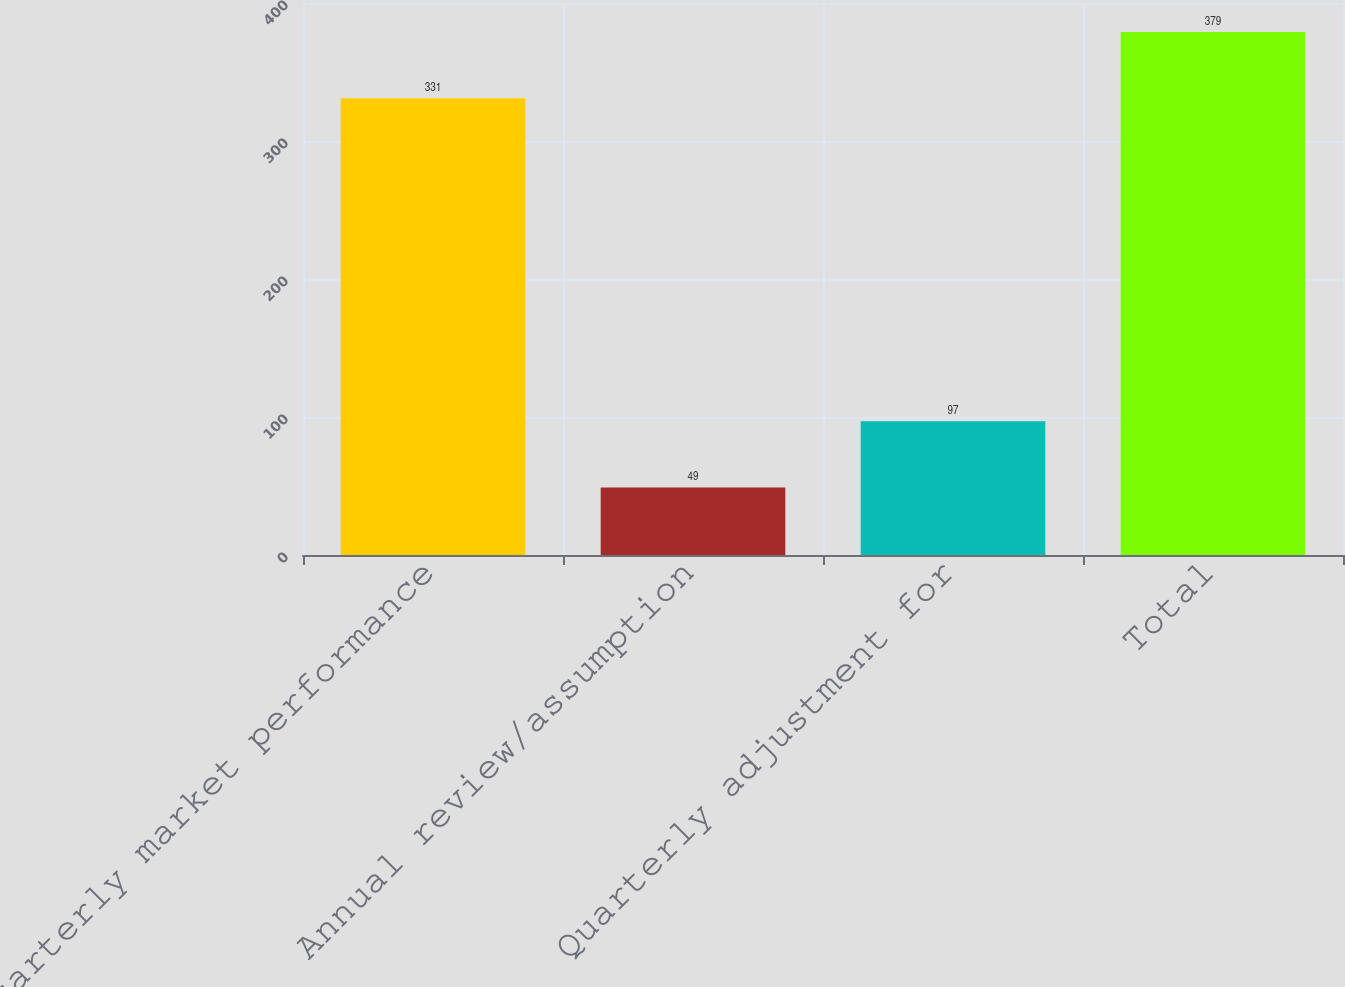<chart> <loc_0><loc_0><loc_500><loc_500><bar_chart><fcel>Quarterly market performance<fcel>Annual review/assumption<fcel>Quarterly adjustment for<fcel>Total<nl><fcel>331<fcel>49<fcel>97<fcel>379<nl></chart> 